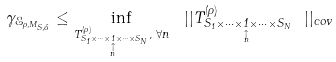Convert formula to latex. <formula><loc_0><loc_0><loc_500><loc_500>\gamma _ { \mathcal { E } _ { \rho , M _ { S , \Lambda } } } \leq \inf _ { T _ { S _ { 1 } \times \cdots \times \underset { \overset { \uparrow } { n } } { 1 } \times \cdots \times S _ { N } } ^ { ( \rho ) } , \text { } \forall n } \text { } | | T _ { S _ { 1 } \times \cdots \times \underset { \overset { \uparrow } { n } } { 1 } \times \cdots \times S _ { N } } ^ { ( \rho ) } \text { } | | _ { c o v }</formula> 